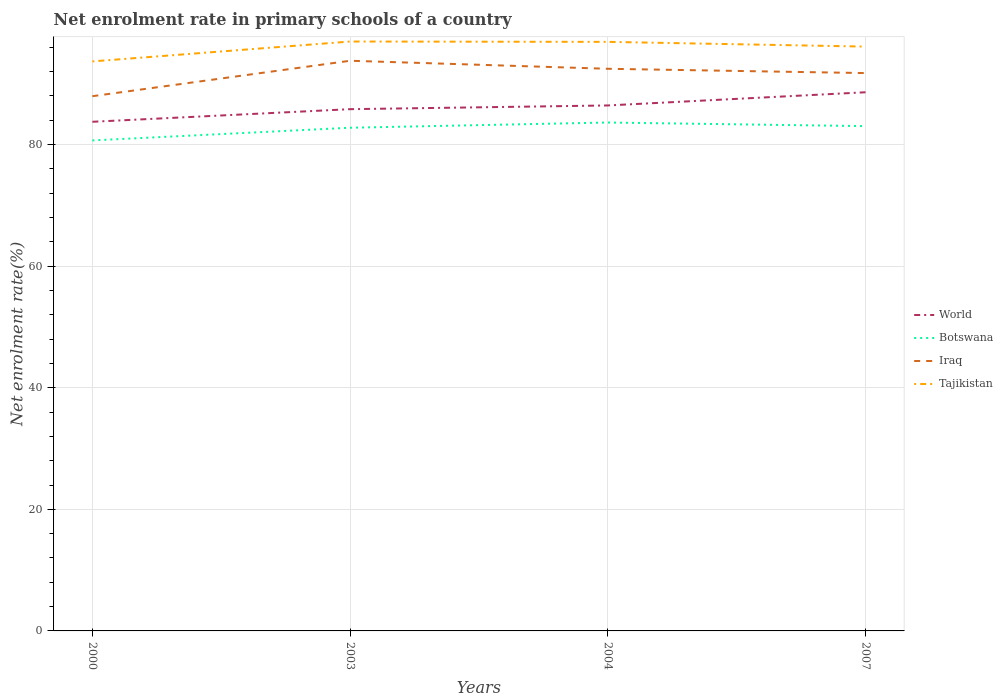Does the line corresponding to Iraq intersect with the line corresponding to Botswana?
Your response must be concise. No. Across all years, what is the maximum net enrolment rate in primary schools in Botswana?
Make the answer very short. 80.68. What is the total net enrolment rate in primary schools in Tajikistan in the graph?
Your answer should be very brief. 0.06. What is the difference between the highest and the second highest net enrolment rate in primary schools in Tajikistan?
Give a very brief answer. 3.27. What is the difference between the highest and the lowest net enrolment rate in primary schools in Botswana?
Provide a succinct answer. 3. Is the net enrolment rate in primary schools in Iraq strictly greater than the net enrolment rate in primary schools in World over the years?
Ensure brevity in your answer.  No. What is the difference between two consecutive major ticks on the Y-axis?
Your answer should be very brief. 20. Are the values on the major ticks of Y-axis written in scientific E-notation?
Make the answer very short. No. Does the graph contain grids?
Provide a short and direct response. Yes. Where does the legend appear in the graph?
Your answer should be compact. Center right. How many legend labels are there?
Offer a terse response. 4. What is the title of the graph?
Your answer should be very brief. Net enrolment rate in primary schools of a country. What is the label or title of the Y-axis?
Keep it short and to the point. Net enrolment rate(%). What is the Net enrolment rate(%) of World in 2000?
Your answer should be very brief. 83.74. What is the Net enrolment rate(%) of Botswana in 2000?
Your answer should be compact. 80.68. What is the Net enrolment rate(%) of Iraq in 2000?
Give a very brief answer. 87.95. What is the Net enrolment rate(%) in Tajikistan in 2000?
Provide a succinct answer. 93.67. What is the Net enrolment rate(%) in World in 2003?
Offer a very short reply. 85.82. What is the Net enrolment rate(%) of Botswana in 2003?
Your response must be concise. 82.76. What is the Net enrolment rate(%) in Iraq in 2003?
Make the answer very short. 93.78. What is the Net enrolment rate(%) of Tajikistan in 2003?
Give a very brief answer. 96.94. What is the Net enrolment rate(%) of World in 2004?
Your response must be concise. 86.43. What is the Net enrolment rate(%) of Botswana in 2004?
Ensure brevity in your answer.  83.62. What is the Net enrolment rate(%) in Iraq in 2004?
Provide a short and direct response. 92.46. What is the Net enrolment rate(%) of Tajikistan in 2004?
Give a very brief answer. 96.89. What is the Net enrolment rate(%) in World in 2007?
Provide a succinct answer. 88.6. What is the Net enrolment rate(%) in Botswana in 2007?
Your answer should be compact. 83.03. What is the Net enrolment rate(%) in Iraq in 2007?
Give a very brief answer. 91.75. What is the Net enrolment rate(%) in Tajikistan in 2007?
Your answer should be compact. 96.11. Across all years, what is the maximum Net enrolment rate(%) of World?
Your answer should be compact. 88.6. Across all years, what is the maximum Net enrolment rate(%) of Botswana?
Make the answer very short. 83.62. Across all years, what is the maximum Net enrolment rate(%) of Iraq?
Your answer should be very brief. 93.78. Across all years, what is the maximum Net enrolment rate(%) of Tajikistan?
Offer a terse response. 96.94. Across all years, what is the minimum Net enrolment rate(%) of World?
Your answer should be compact. 83.74. Across all years, what is the minimum Net enrolment rate(%) of Botswana?
Your response must be concise. 80.68. Across all years, what is the minimum Net enrolment rate(%) of Iraq?
Make the answer very short. 87.95. Across all years, what is the minimum Net enrolment rate(%) of Tajikistan?
Ensure brevity in your answer.  93.67. What is the total Net enrolment rate(%) in World in the graph?
Provide a short and direct response. 344.59. What is the total Net enrolment rate(%) in Botswana in the graph?
Offer a very short reply. 330.09. What is the total Net enrolment rate(%) in Iraq in the graph?
Offer a terse response. 365.95. What is the total Net enrolment rate(%) in Tajikistan in the graph?
Give a very brief answer. 383.61. What is the difference between the Net enrolment rate(%) of World in 2000 and that in 2003?
Offer a terse response. -2.07. What is the difference between the Net enrolment rate(%) in Botswana in 2000 and that in 2003?
Your answer should be very brief. -2.09. What is the difference between the Net enrolment rate(%) in Iraq in 2000 and that in 2003?
Give a very brief answer. -5.83. What is the difference between the Net enrolment rate(%) of Tajikistan in 2000 and that in 2003?
Your answer should be compact. -3.27. What is the difference between the Net enrolment rate(%) of World in 2000 and that in 2004?
Offer a very short reply. -2.68. What is the difference between the Net enrolment rate(%) of Botswana in 2000 and that in 2004?
Provide a short and direct response. -2.95. What is the difference between the Net enrolment rate(%) in Iraq in 2000 and that in 2004?
Keep it short and to the point. -4.51. What is the difference between the Net enrolment rate(%) of Tajikistan in 2000 and that in 2004?
Offer a terse response. -3.22. What is the difference between the Net enrolment rate(%) of World in 2000 and that in 2007?
Give a very brief answer. -4.86. What is the difference between the Net enrolment rate(%) of Botswana in 2000 and that in 2007?
Provide a short and direct response. -2.35. What is the difference between the Net enrolment rate(%) in Iraq in 2000 and that in 2007?
Your answer should be compact. -3.8. What is the difference between the Net enrolment rate(%) of Tajikistan in 2000 and that in 2007?
Offer a very short reply. -2.44. What is the difference between the Net enrolment rate(%) of World in 2003 and that in 2004?
Offer a terse response. -0.61. What is the difference between the Net enrolment rate(%) of Botswana in 2003 and that in 2004?
Your answer should be very brief. -0.86. What is the difference between the Net enrolment rate(%) of Iraq in 2003 and that in 2004?
Your response must be concise. 1.32. What is the difference between the Net enrolment rate(%) of Tajikistan in 2003 and that in 2004?
Offer a very short reply. 0.06. What is the difference between the Net enrolment rate(%) in World in 2003 and that in 2007?
Offer a terse response. -2.78. What is the difference between the Net enrolment rate(%) in Botswana in 2003 and that in 2007?
Offer a very short reply. -0.26. What is the difference between the Net enrolment rate(%) in Iraq in 2003 and that in 2007?
Your response must be concise. 2.03. What is the difference between the Net enrolment rate(%) of Tajikistan in 2003 and that in 2007?
Ensure brevity in your answer.  0.84. What is the difference between the Net enrolment rate(%) in World in 2004 and that in 2007?
Your answer should be very brief. -2.17. What is the difference between the Net enrolment rate(%) in Botswana in 2004 and that in 2007?
Offer a very short reply. 0.59. What is the difference between the Net enrolment rate(%) in Iraq in 2004 and that in 2007?
Your response must be concise. 0.71. What is the difference between the Net enrolment rate(%) in Tajikistan in 2004 and that in 2007?
Provide a short and direct response. 0.78. What is the difference between the Net enrolment rate(%) of World in 2000 and the Net enrolment rate(%) of Botswana in 2003?
Your response must be concise. 0.98. What is the difference between the Net enrolment rate(%) in World in 2000 and the Net enrolment rate(%) in Iraq in 2003?
Your response must be concise. -10.04. What is the difference between the Net enrolment rate(%) in World in 2000 and the Net enrolment rate(%) in Tajikistan in 2003?
Provide a short and direct response. -13.2. What is the difference between the Net enrolment rate(%) in Botswana in 2000 and the Net enrolment rate(%) in Iraq in 2003?
Provide a succinct answer. -13.1. What is the difference between the Net enrolment rate(%) in Botswana in 2000 and the Net enrolment rate(%) in Tajikistan in 2003?
Provide a short and direct response. -16.27. What is the difference between the Net enrolment rate(%) in Iraq in 2000 and the Net enrolment rate(%) in Tajikistan in 2003?
Your answer should be very brief. -8.99. What is the difference between the Net enrolment rate(%) of World in 2000 and the Net enrolment rate(%) of Botswana in 2004?
Give a very brief answer. 0.12. What is the difference between the Net enrolment rate(%) in World in 2000 and the Net enrolment rate(%) in Iraq in 2004?
Your answer should be very brief. -8.72. What is the difference between the Net enrolment rate(%) of World in 2000 and the Net enrolment rate(%) of Tajikistan in 2004?
Give a very brief answer. -13.14. What is the difference between the Net enrolment rate(%) in Botswana in 2000 and the Net enrolment rate(%) in Iraq in 2004?
Your answer should be compact. -11.78. What is the difference between the Net enrolment rate(%) in Botswana in 2000 and the Net enrolment rate(%) in Tajikistan in 2004?
Keep it short and to the point. -16.21. What is the difference between the Net enrolment rate(%) in Iraq in 2000 and the Net enrolment rate(%) in Tajikistan in 2004?
Your answer should be very brief. -8.94. What is the difference between the Net enrolment rate(%) in World in 2000 and the Net enrolment rate(%) in Botswana in 2007?
Give a very brief answer. 0.72. What is the difference between the Net enrolment rate(%) in World in 2000 and the Net enrolment rate(%) in Iraq in 2007?
Give a very brief answer. -8.01. What is the difference between the Net enrolment rate(%) of World in 2000 and the Net enrolment rate(%) of Tajikistan in 2007?
Provide a succinct answer. -12.36. What is the difference between the Net enrolment rate(%) of Botswana in 2000 and the Net enrolment rate(%) of Iraq in 2007?
Keep it short and to the point. -11.08. What is the difference between the Net enrolment rate(%) in Botswana in 2000 and the Net enrolment rate(%) in Tajikistan in 2007?
Keep it short and to the point. -15.43. What is the difference between the Net enrolment rate(%) in Iraq in 2000 and the Net enrolment rate(%) in Tajikistan in 2007?
Offer a terse response. -8.16. What is the difference between the Net enrolment rate(%) in World in 2003 and the Net enrolment rate(%) in Botswana in 2004?
Your answer should be very brief. 2.2. What is the difference between the Net enrolment rate(%) of World in 2003 and the Net enrolment rate(%) of Iraq in 2004?
Your response must be concise. -6.64. What is the difference between the Net enrolment rate(%) in World in 2003 and the Net enrolment rate(%) in Tajikistan in 2004?
Your response must be concise. -11.07. What is the difference between the Net enrolment rate(%) of Botswana in 2003 and the Net enrolment rate(%) of Iraq in 2004?
Your response must be concise. -9.7. What is the difference between the Net enrolment rate(%) in Botswana in 2003 and the Net enrolment rate(%) in Tajikistan in 2004?
Offer a terse response. -14.12. What is the difference between the Net enrolment rate(%) of Iraq in 2003 and the Net enrolment rate(%) of Tajikistan in 2004?
Give a very brief answer. -3.11. What is the difference between the Net enrolment rate(%) of World in 2003 and the Net enrolment rate(%) of Botswana in 2007?
Provide a short and direct response. 2.79. What is the difference between the Net enrolment rate(%) in World in 2003 and the Net enrolment rate(%) in Iraq in 2007?
Offer a very short reply. -5.94. What is the difference between the Net enrolment rate(%) of World in 2003 and the Net enrolment rate(%) of Tajikistan in 2007?
Provide a short and direct response. -10.29. What is the difference between the Net enrolment rate(%) in Botswana in 2003 and the Net enrolment rate(%) in Iraq in 2007?
Make the answer very short. -8.99. What is the difference between the Net enrolment rate(%) in Botswana in 2003 and the Net enrolment rate(%) in Tajikistan in 2007?
Offer a very short reply. -13.35. What is the difference between the Net enrolment rate(%) of Iraq in 2003 and the Net enrolment rate(%) of Tajikistan in 2007?
Your response must be concise. -2.33. What is the difference between the Net enrolment rate(%) in World in 2004 and the Net enrolment rate(%) in Botswana in 2007?
Offer a very short reply. 3.4. What is the difference between the Net enrolment rate(%) of World in 2004 and the Net enrolment rate(%) of Iraq in 2007?
Your answer should be very brief. -5.32. What is the difference between the Net enrolment rate(%) of World in 2004 and the Net enrolment rate(%) of Tajikistan in 2007?
Provide a succinct answer. -9.68. What is the difference between the Net enrolment rate(%) in Botswana in 2004 and the Net enrolment rate(%) in Iraq in 2007?
Keep it short and to the point. -8.13. What is the difference between the Net enrolment rate(%) in Botswana in 2004 and the Net enrolment rate(%) in Tajikistan in 2007?
Offer a very short reply. -12.49. What is the difference between the Net enrolment rate(%) of Iraq in 2004 and the Net enrolment rate(%) of Tajikistan in 2007?
Offer a terse response. -3.65. What is the average Net enrolment rate(%) of World per year?
Give a very brief answer. 86.15. What is the average Net enrolment rate(%) of Botswana per year?
Offer a terse response. 82.52. What is the average Net enrolment rate(%) in Iraq per year?
Provide a short and direct response. 91.49. What is the average Net enrolment rate(%) in Tajikistan per year?
Provide a succinct answer. 95.9. In the year 2000, what is the difference between the Net enrolment rate(%) in World and Net enrolment rate(%) in Botswana?
Make the answer very short. 3.07. In the year 2000, what is the difference between the Net enrolment rate(%) of World and Net enrolment rate(%) of Iraq?
Make the answer very short. -4.21. In the year 2000, what is the difference between the Net enrolment rate(%) in World and Net enrolment rate(%) in Tajikistan?
Your answer should be compact. -9.93. In the year 2000, what is the difference between the Net enrolment rate(%) in Botswana and Net enrolment rate(%) in Iraq?
Ensure brevity in your answer.  -7.27. In the year 2000, what is the difference between the Net enrolment rate(%) in Botswana and Net enrolment rate(%) in Tajikistan?
Provide a short and direct response. -13. In the year 2000, what is the difference between the Net enrolment rate(%) of Iraq and Net enrolment rate(%) of Tajikistan?
Provide a short and direct response. -5.72. In the year 2003, what is the difference between the Net enrolment rate(%) in World and Net enrolment rate(%) in Botswana?
Offer a terse response. 3.05. In the year 2003, what is the difference between the Net enrolment rate(%) in World and Net enrolment rate(%) in Iraq?
Provide a short and direct response. -7.96. In the year 2003, what is the difference between the Net enrolment rate(%) in World and Net enrolment rate(%) in Tajikistan?
Provide a succinct answer. -11.13. In the year 2003, what is the difference between the Net enrolment rate(%) in Botswana and Net enrolment rate(%) in Iraq?
Make the answer very short. -11.02. In the year 2003, what is the difference between the Net enrolment rate(%) in Botswana and Net enrolment rate(%) in Tajikistan?
Keep it short and to the point. -14.18. In the year 2003, what is the difference between the Net enrolment rate(%) of Iraq and Net enrolment rate(%) of Tajikistan?
Give a very brief answer. -3.16. In the year 2004, what is the difference between the Net enrolment rate(%) in World and Net enrolment rate(%) in Botswana?
Offer a very short reply. 2.81. In the year 2004, what is the difference between the Net enrolment rate(%) of World and Net enrolment rate(%) of Iraq?
Ensure brevity in your answer.  -6.03. In the year 2004, what is the difference between the Net enrolment rate(%) in World and Net enrolment rate(%) in Tajikistan?
Keep it short and to the point. -10.46. In the year 2004, what is the difference between the Net enrolment rate(%) in Botswana and Net enrolment rate(%) in Iraq?
Offer a terse response. -8.84. In the year 2004, what is the difference between the Net enrolment rate(%) of Botswana and Net enrolment rate(%) of Tajikistan?
Offer a very short reply. -13.27. In the year 2004, what is the difference between the Net enrolment rate(%) of Iraq and Net enrolment rate(%) of Tajikistan?
Ensure brevity in your answer.  -4.43. In the year 2007, what is the difference between the Net enrolment rate(%) in World and Net enrolment rate(%) in Botswana?
Give a very brief answer. 5.57. In the year 2007, what is the difference between the Net enrolment rate(%) in World and Net enrolment rate(%) in Iraq?
Your answer should be very brief. -3.15. In the year 2007, what is the difference between the Net enrolment rate(%) in World and Net enrolment rate(%) in Tajikistan?
Provide a short and direct response. -7.51. In the year 2007, what is the difference between the Net enrolment rate(%) of Botswana and Net enrolment rate(%) of Iraq?
Offer a terse response. -8.73. In the year 2007, what is the difference between the Net enrolment rate(%) in Botswana and Net enrolment rate(%) in Tajikistan?
Provide a short and direct response. -13.08. In the year 2007, what is the difference between the Net enrolment rate(%) in Iraq and Net enrolment rate(%) in Tajikistan?
Your answer should be very brief. -4.36. What is the ratio of the Net enrolment rate(%) of World in 2000 to that in 2003?
Offer a terse response. 0.98. What is the ratio of the Net enrolment rate(%) in Botswana in 2000 to that in 2003?
Offer a terse response. 0.97. What is the ratio of the Net enrolment rate(%) in Iraq in 2000 to that in 2003?
Provide a short and direct response. 0.94. What is the ratio of the Net enrolment rate(%) in Tajikistan in 2000 to that in 2003?
Offer a very short reply. 0.97. What is the ratio of the Net enrolment rate(%) in World in 2000 to that in 2004?
Keep it short and to the point. 0.97. What is the ratio of the Net enrolment rate(%) in Botswana in 2000 to that in 2004?
Keep it short and to the point. 0.96. What is the ratio of the Net enrolment rate(%) of Iraq in 2000 to that in 2004?
Give a very brief answer. 0.95. What is the ratio of the Net enrolment rate(%) in Tajikistan in 2000 to that in 2004?
Provide a short and direct response. 0.97. What is the ratio of the Net enrolment rate(%) of World in 2000 to that in 2007?
Give a very brief answer. 0.95. What is the ratio of the Net enrolment rate(%) of Botswana in 2000 to that in 2007?
Your answer should be compact. 0.97. What is the ratio of the Net enrolment rate(%) of Iraq in 2000 to that in 2007?
Provide a short and direct response. 0.96. What is the ratio of the Net enrolment rate(%) in Tajikistan in 2000 to that in 2007?
Keep it short and to the point. 0.97. What is the ratio of the Net enrolment rate(%) in Botswana in 2003 to that in 2004?
Ensure brevity in your answer.  0.99. What is the ratio of the Net enrolment rate(%) of Iraq in 2003 to that in 2004?
Provide a succinct answer. 1.01. What is the ratio of the Net enrolment rate(%) in Tajikistan in 2003 to that in 2004?
Make the answer very short. 1. What is the ratio of the Net enrolment rate(%) of World in 2003 to that in 2007?
Provide a succinct answer. 0.97. What is the ratio of the Net enrolment rate(%) in Botswana in 2003 to that in 2007?
Offer a terse response. 1. What is the ratio of the Net enrolment rate(%) of Iraq in 2003 to that in 2007?
Make the answer very short. 1.02. What is the ratio of the Net enrolment rate(%) of Tajikistan in 2003 to that in 2007?
Keep it short and to the point. 1.01. What is the ratio of the Net enrolment rate(%) in World in 2004 to that in 2007?
Offer a terse response. 0.98. What is the ratio of the Net enrolment rate(%) of Iraq in 2004 to that in 2007?
Provide a short and direct response. 1.01. What is the ratio of the Net enrolment rate(%) of Tajikistan in 2004 to that in 2007?
Make the answer very short. 1.01. What is the difference between the highest and the second highest Net enrolment rate(%) of World?
Provide a succinct answer. 2.17. What is the difference between the highest and the second highest Net enrolment rate(%) of Botswana?
Provide a succinct answer. 0.59. What is the difference between the highest and the second highest Net enrolment rate(%) in Iraq?
Make the answer very short. 1.32. What is the difference between the highest and the second highest Net enrolment rate(%) of Tajikistan?
Keep it short and to the point. 0.06. What is the difference between the highest and the lowest Net enrolment rate(%) of World?
Make the answer very short. 4.86. What is the difference between the highest and the lowest Net enrolment rate(%) in Botswana?
Your response must be concise. 2.95. What is the difference between the highest and the lowest Net enrolment rate(%) of Iraq?
Give a very brief answer. 5.83. What is the difference between the highest and the lowest Net enrolment rate(%) in Tajikistan?
Provide a short and direct response. 3.27. 